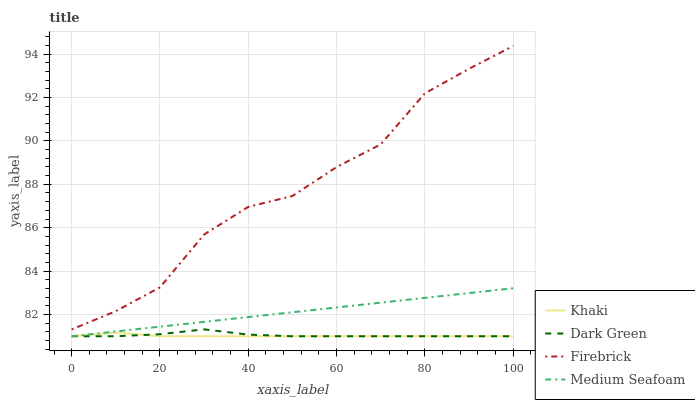Does Medium Seafoam have the minimum area under the curve?
Answer yes or no. No. Does Medium Seafoam have the maximum area under the curve?
Answer yes or no. No. Is Khaki the smoothest?
Answer yes or no. No. Is Khaki the roughest?
Answer yes or no. No. Does Medium Seafoam have the highest value?
Answer yes or no. No. Is Dark Green less than Firebrick?
Answer yes or no. Yes. Is Firebrick greater than Medium Seafoam?
Answer yes or no. Yes. Does Dark Green intersect Firebrick?
Answer yes or no. No. 